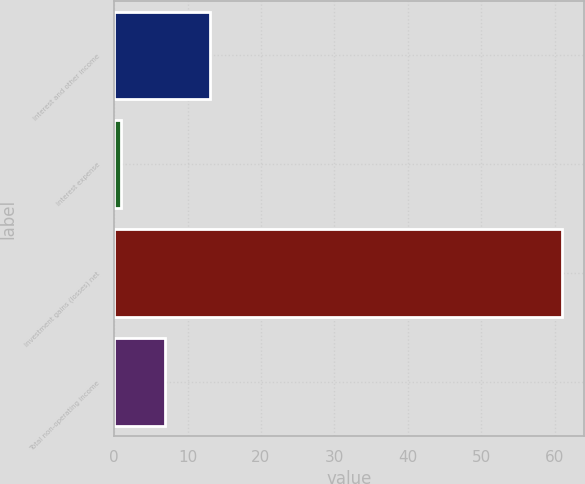<chart> <loc_0><loc_0><loc_500><loc_500><bar_chart><fcel>Interest and other income<fcel>Interest expense<fcel>Investment gains (losses) net<fcel>Total non-operating income<nl><fcel>13<fcel>1<fcel>61<fcel>7<nl></chart> 